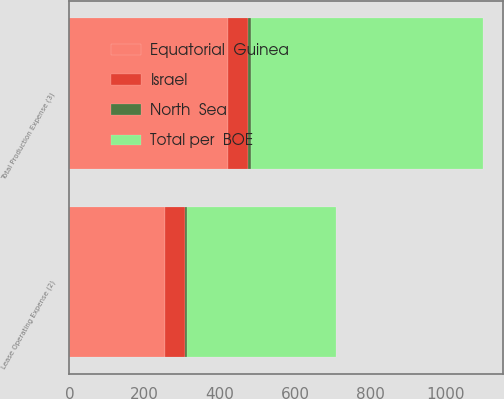Convert chart to OTSL. <chart><loc_0><loc_0><loc_500><loc_500><stacked_bar_chart><ecel><fcel>Lease Operating Expense (2)<fcel>Total Production Expense (3)<nl><fcel>North  Sea<fcel>5.07<fcel>7.9<nl><fcel>Total per  BOE<fcel>397<fcel>618<nl><fcel>Equatorial  Guinea<fcel>254<fcel>421<nl><fcel>Israel<fcel>53<fcel>53<nl></chart> 